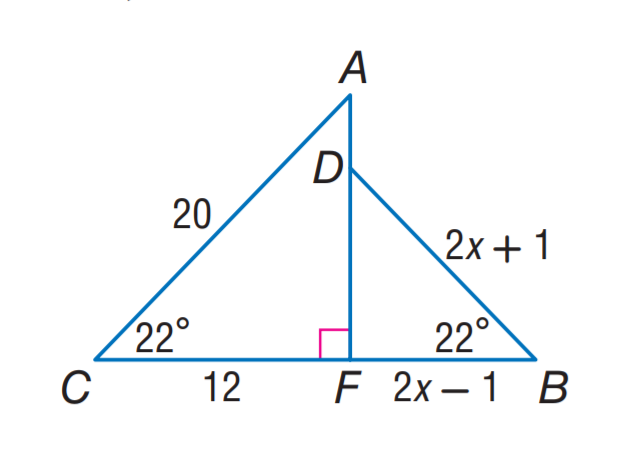Answer the mathemtical geometry problem and directly provide the correct option letter.
Question: Find C B.
Choices: A: 5 B: 12 C: 15 D: 20 C 